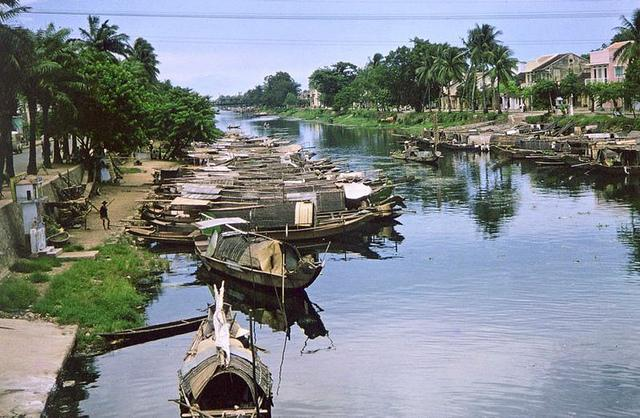What powers those boats? kinetic energy 